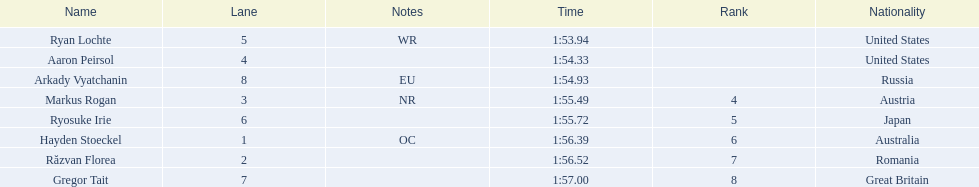Who are the swimmers? Ryan Lochte, Aaron Peirsol, Arkady Vyatchanin, Markus Rogan, Ryosuke Irie, Hayden Stoeckel, Răzvan Florea, Gregor Tait. What is ryosuke irie's time? 1:55.72. 